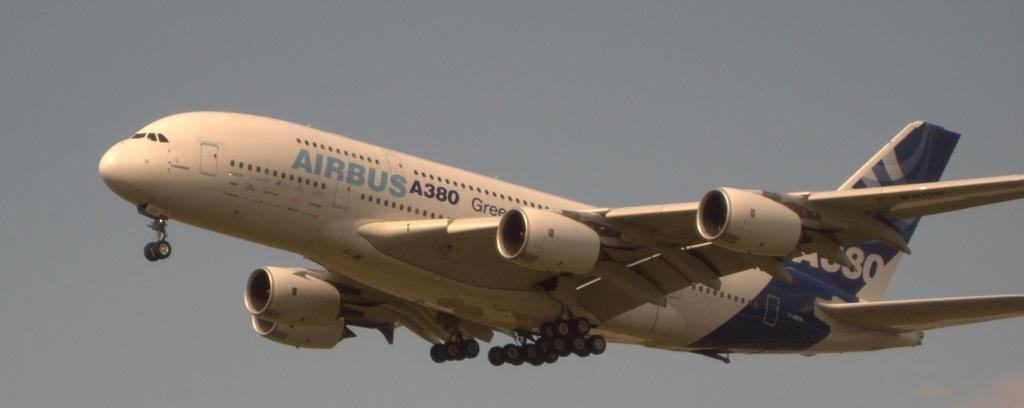Provide a one-sentence caption for the provided image. An Airbus 380 jet is in the air. 